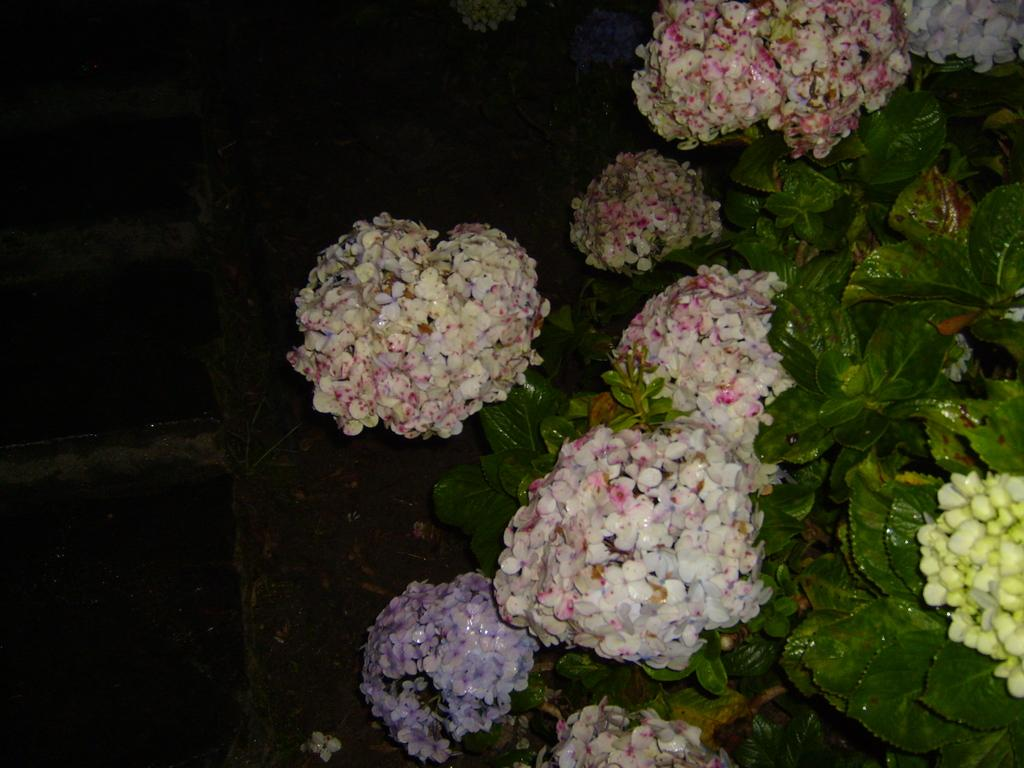What types of living organisms can be seen in the image? There are many plants in the image. Can you describe any specific features of the plants? Yes, there are flowers present in the image. What type of board is being used for the operation in the image? There is no board or operation present in the image; it features many plants and flowers. 